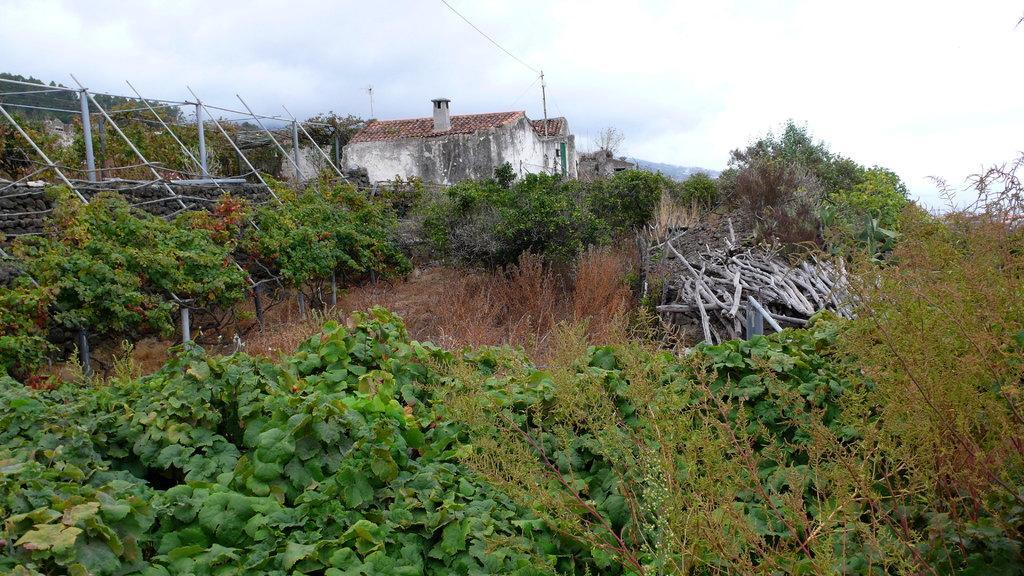In one or two sentences, can you explain what this image depicts? There are plants, woods and dry plants on the ground, near poles arranged, there are houses, mountains and clouds in the sky. 